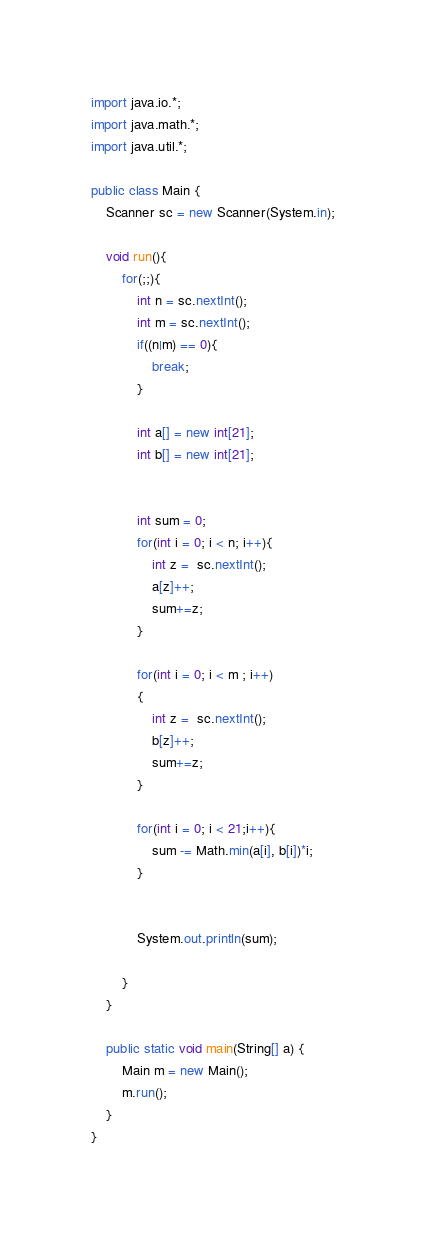<code> <loc_0><loc_0><loc_500><loc_500><_Java_>import java.io.*;
import java.math.*;
import java.util.*;

public class Main {
	Scanner sc = new Scanner(System.in);

	void run(){
		for(;;){
			int n = sc.nextInt();
			int m = sc.nextInt();
			if((n|m) == 0){
				break;
			}
			
			int a[] = new int[21];
			int b[] = new int[21];
			 
			
			int sum = 0;
			for(int i = 0; i < n; i++){
				int z =  sc.nextInt();
				a[z]++;
				sum+=z;
			}
			
			for(int i = 0; i < m ; i++)
			{
				int z =  sc.nextInt();
				b[z]++;
				sum+=z;
			}
			
			for(int i = 0; i < 21;i++){
				sum -= Math.min(a[i], b[i])*i;
			}
			
			
			System.out.println(sum);
			
		}
	}
	
	public static void main(String[] a) {
		Main m = new Main();
		m.run();
	}
}</code> 